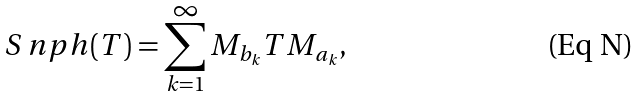Convert formula to latex. <formula><loc_0><loc_0><loc_500><loc_500>S _ { \ } n p h ( T ) = \sum _ { k = 1 } ^ { \infty } M _ { b _ { k } } T M _ { a _ { k } } ,</formula> 